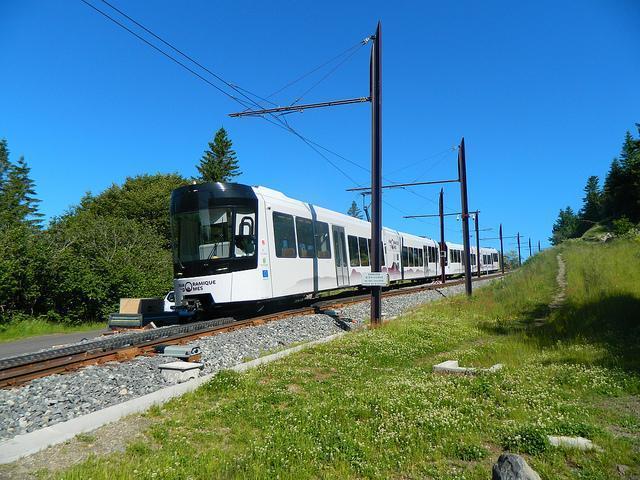How many poles are there?
Give a very brief answer. 8. 